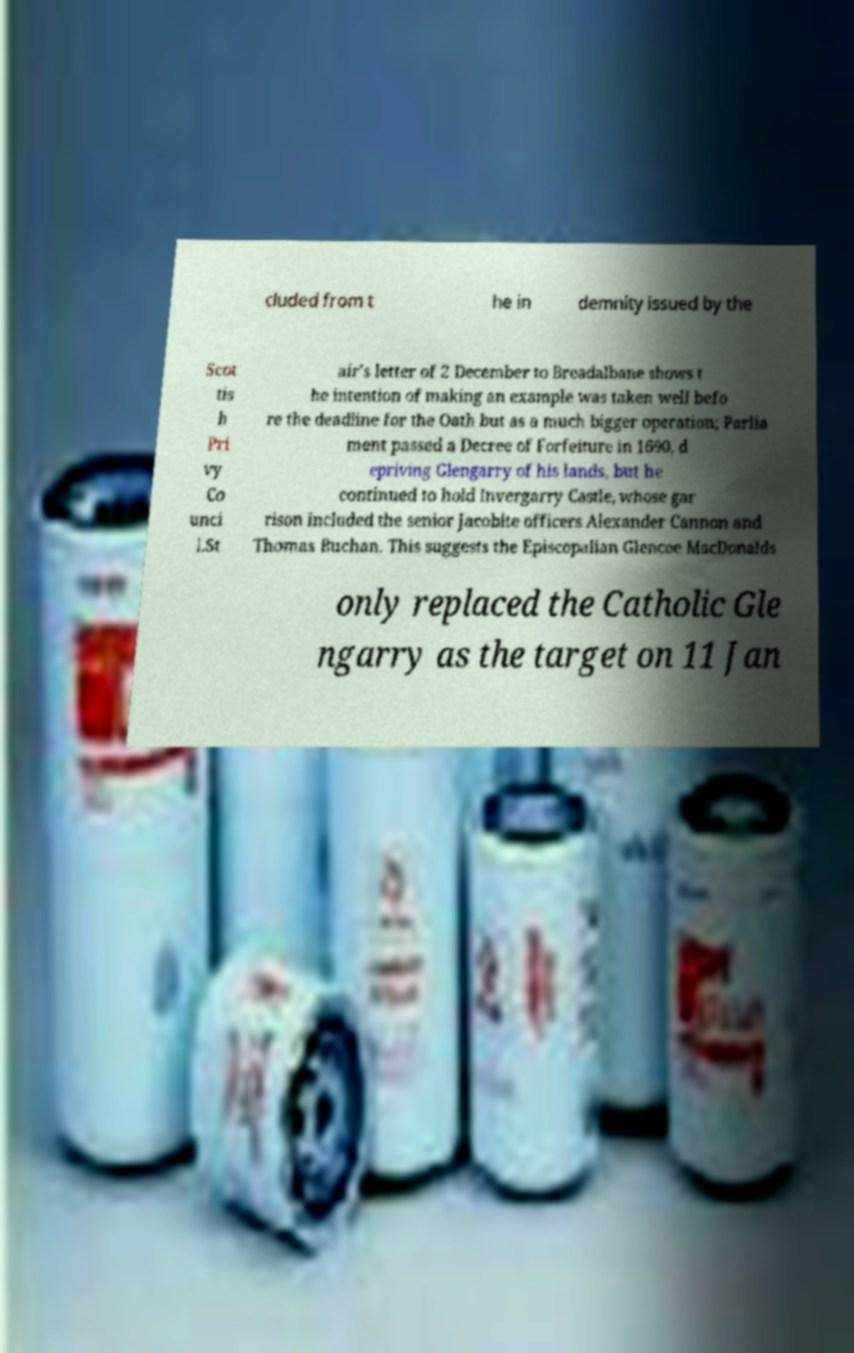There's text embedded in this image that I need extracted. Can you transcribe it verbatim? cluded from t he in demnity issued by the Scot tis h Pri vy Co unci l.St air's letter of 2 December to Breadalbane shows t he intention of making an example was taken well befo re the deadline for the Oath but as a much bigger operation; Parlia ment passed a Decree of Forfeiture in 1690, d epriving Glengarry of his lands, but he continued to hold Invergarry Castle, whose gar rison included the senior Jacobite officers Alexander Cannon and Thomas Buchan. This suggests the Episcopalian Glencoe MacDonalds only replaced the Catholic Gle ngarry as the target on 11 Jan 